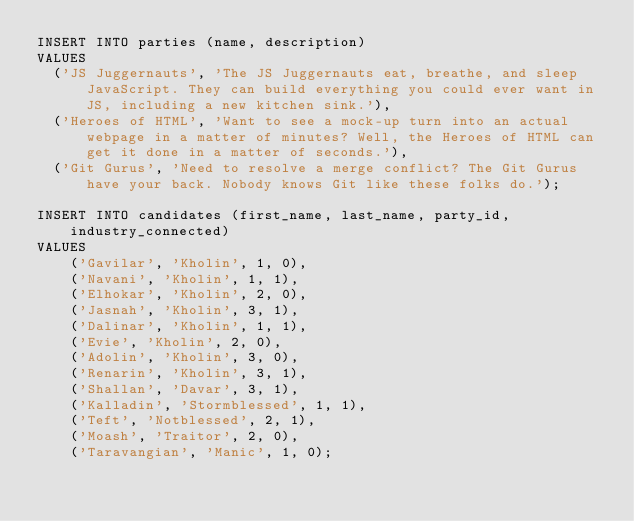Convert code to text. <code><loc_0><loc_0><loc_500><loc_500><_SQL_>INSERT INTO parties (name, description)
VALUES
  ('JS Juggernauts', 'The JS Juggernauts eat, breathe, and sleep JavaScript. They can build everything you could ever want in JS, including a new kitchen sink.'),
  ('Heroes of HTML', 'Want to see a mock-up turn into an actual webpage in a matter of minutes? Well, the Heroes of HTML can get it done in a matter of seconds.'),
  ('Git Gurus', 'Need to resolve a merge conflict? The Git Gurus have your back. Nobody knows Git like these folks do.');

INSERT INTO candidates (first_name, last_name, party_id, industry_connected)
VALUES
    ('Gavilar', 'Kholin', 1, 0),
    ('Navani', 'Kholin', 1, 1),
    ('Elhokar', 'Kholin', 2, 0),
    ('Jasnah', 'Kholin', 3, 1),
    ('Dalinar', 'Kholin', 1, 1),
    ('Evie', 'Kholin', 2, 0),
    ('Adolin', 'Kholin', 3, 0),
    ('Renarin', 'Kholin', 3, 1),
    ('Shallan', 'Davar', 3, 1),
    ('Kalladin', 'Stormblessed', 1, 1),
    ('Teft', 'Notblessed', 2, 1),
    ('Moash', 'Traitor', 2, 0),
    ('Taravangian', 'Manic', 1, 0);
</code> 